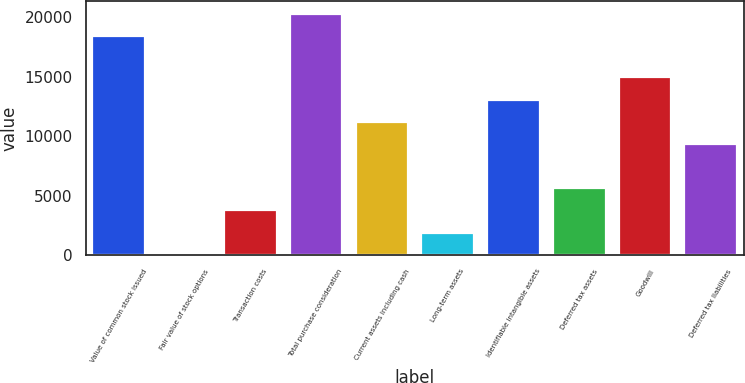Convert chart. <chart><loc_0><loc_0><loc_500><loc_500><bar_chart><fcel>Value of common stock issued<fcel>Fair value of stock options<fcel>Transaction costs<fcel>Total purchase consideration<fcel>Current assets including cash<fcel>Long-term assets<fcel>Identifiable intangible assets<fcel>Deferred tax assets<fcel>Goodwill<fcel>Deferred tax liabilities<nl><fcel>18449<fcel>4<fcel>3741.2<fcel>20317.6<fcel>11215.6<fcel>1872.6<fcel>13084.2<fcel>5609.8<fcel>14952.8<fcel>9347<nl></chart> 